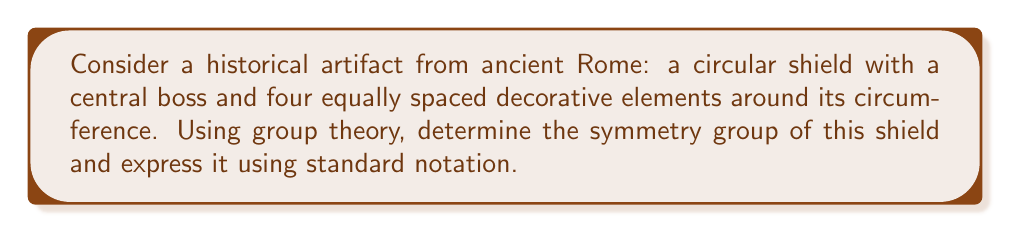Give your solution to this math problem. To determine the symmetry group of this historical artifact, we'll follow these steps:

1. Identify the symmetries:
   - Rotational symmetry: The shield can be rotated by 90°, 180°, 270°, and 360° (identity) about its center.
   - Reflection symmetry: The shield has 4 lines of reflection (through the decorative elements and between them).

2. Count the number of symmetries:
   - 4 rotations (including identity)
   - 4 reflections
   Total: 8 symmetries

3. Recognize the group structure:
   - The symmetries form a group under composition.
   - This group has 8 elements and contains both rotations and reflections.
   - The structure matches the dihedral group of order 8, denoted as $D_4$ or $D_8$ (depending on the notation system).

4. Express the group using standard notation:
   In abstract algebra, this group is commonly written as:
   
   $$D_4 = \langle r, s \mid r^4 = s^2 = 1, srs = r^{-1} \rangle$$

   Where $r$ represents a 90° rotation and $s$ represents a reflection.

5. Historical context:
   Understanding the symmetry group of historical artifacts can provide insights into the mathematical knowledge and aesthetic preferences of ancient civilizations, enhancing the accuracy of historical reenactments.
Answer: $D_4$ or $D_8$ 